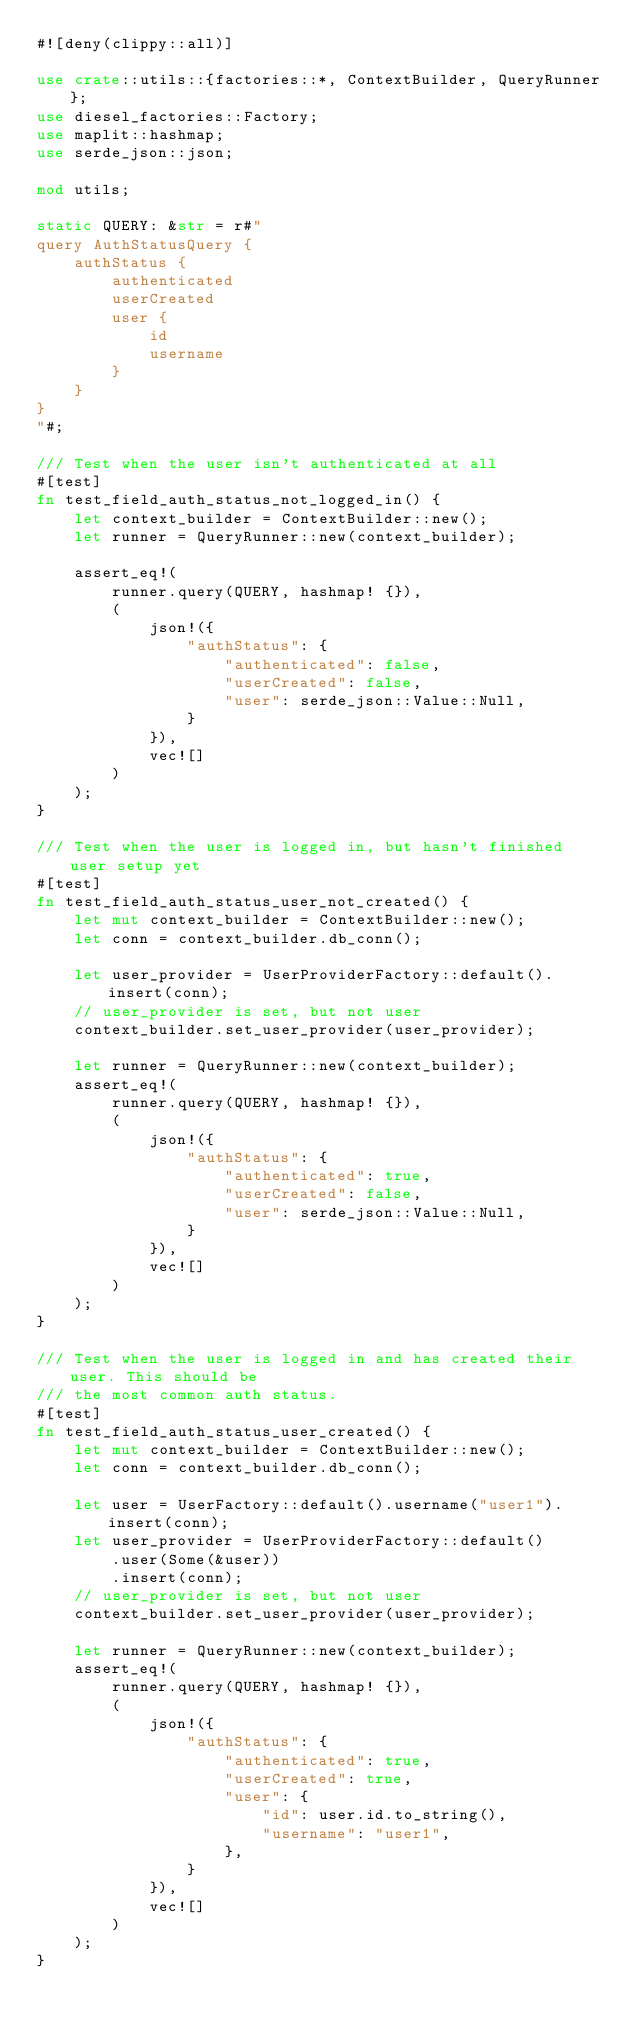Convert code to text. <code><loc_0><loc_0><loc_500><loc_500><_Rust_>#![deny(clippy::all)]

use crate::utils::{factories::*, ContextBuilder, QueryRunner};
use diesel_factories::Factory;
use maplit::hashmap;
use serde_json::json;

mod utils;

static QUERY: &str = r#"
query AuthStatusQuery {
    authStatus {
        authenticated
        userCreated
        user {
            id
            username
        }
    }
}
"#;

/// Test when the user isn't authenticated at all
#[test]
fn test_field_auth_status_not_logged_in() {
    let context_builder = ContextBuilder::new();
    let runner = QueryRunner::new(context_builder);

    assert_eq!(
        runner.query(QUERY, hashmap! {}),
        (
            json!({
                "authStatus": {
                    "authenticated": false,
                    "userCreated": false,
                    "user": serde_json::Value::Null,
                }
            }),
            vec![]
        )
    );
}

/// Test when the user is logged in, but hasn't finished user setup yet
#[test]
fn test_field_auth_status_user_not_created() {
    let mut context_builder = ContextBuilder::new();
    let conn = context_builder.db_conn();

    let user_provider = UserProviderFactory::default().insert(conn);
    // user_provider is set, but not user
    context_builder.set_user_provider(user_provider);

    let runner = QueryRunner::new(context_builder);
    assert_eq!(
        runner.query(QUERY, hashmap! {}),
        (
            json!({
                "authStatus": {
                    "authenticated": true,
                    "userCreated": false,
                    "user": serde_json::Value::Null,
                }
            }),
            vec![]
        )
    );
}

/// Test when the user is logged in and has created their user. This should be
/// the most common auth status.
#[test]
fn test_field_auth_status_user_created() {
    let mut context_builder = ContextBuilder::new();
    let conn = context_builder.db_conn();

    let user = UserFactory::default().username("user1").insert(conn);
    let user_provider = UserProviderFactory::default()
        .user(Some(&user))
        .insert(conn);
    // user_provider is set, but not user
    context_builder.set_user_provider(user_provider);

    let runner = QueryRunner::new(context_builder);
    assert_eq!(
        runner.query(QUERY, hashmap! {}),
        (
            json!({
                "authStatus": {
                    "authenticated": true,
                    "userCreated": true,
                    "user": {
                        "id": user.id.to_string(),
                        "username": "user1",
                    },
                }
            }),
            vec![]
        )
    );
}
</code> 